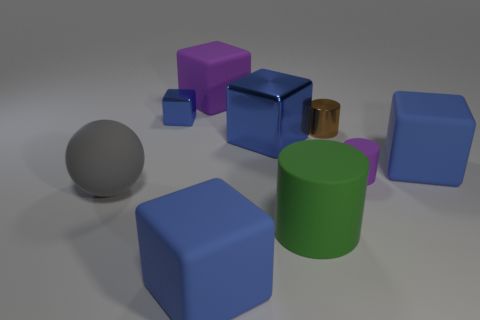Subtract all blue cubes. How many were subtracted if there are2blue cubes left? 2 Subtract all gray cylinders. How many blue cubes are left? 4 Subtract all small blue cubes. How many cubes are left? 4 Subtract all purple blocks. How many blocks are left? 4 Subtract 2 cubes. How many cubes are left? 3 Subtract all yellow blocks. Subtract all red cylinders. How many blocks are left? 5 Subtract all spheres. How many objects are left? 8 Subtract all large gray balls. Subtract all large blue blocks. How many objects are left? 5 Add 3 large gray rubber objects. How many large gray rubber objects are left? 4 Add 3 large cyan matte balls. How many large cyan matte balls exist? 3 